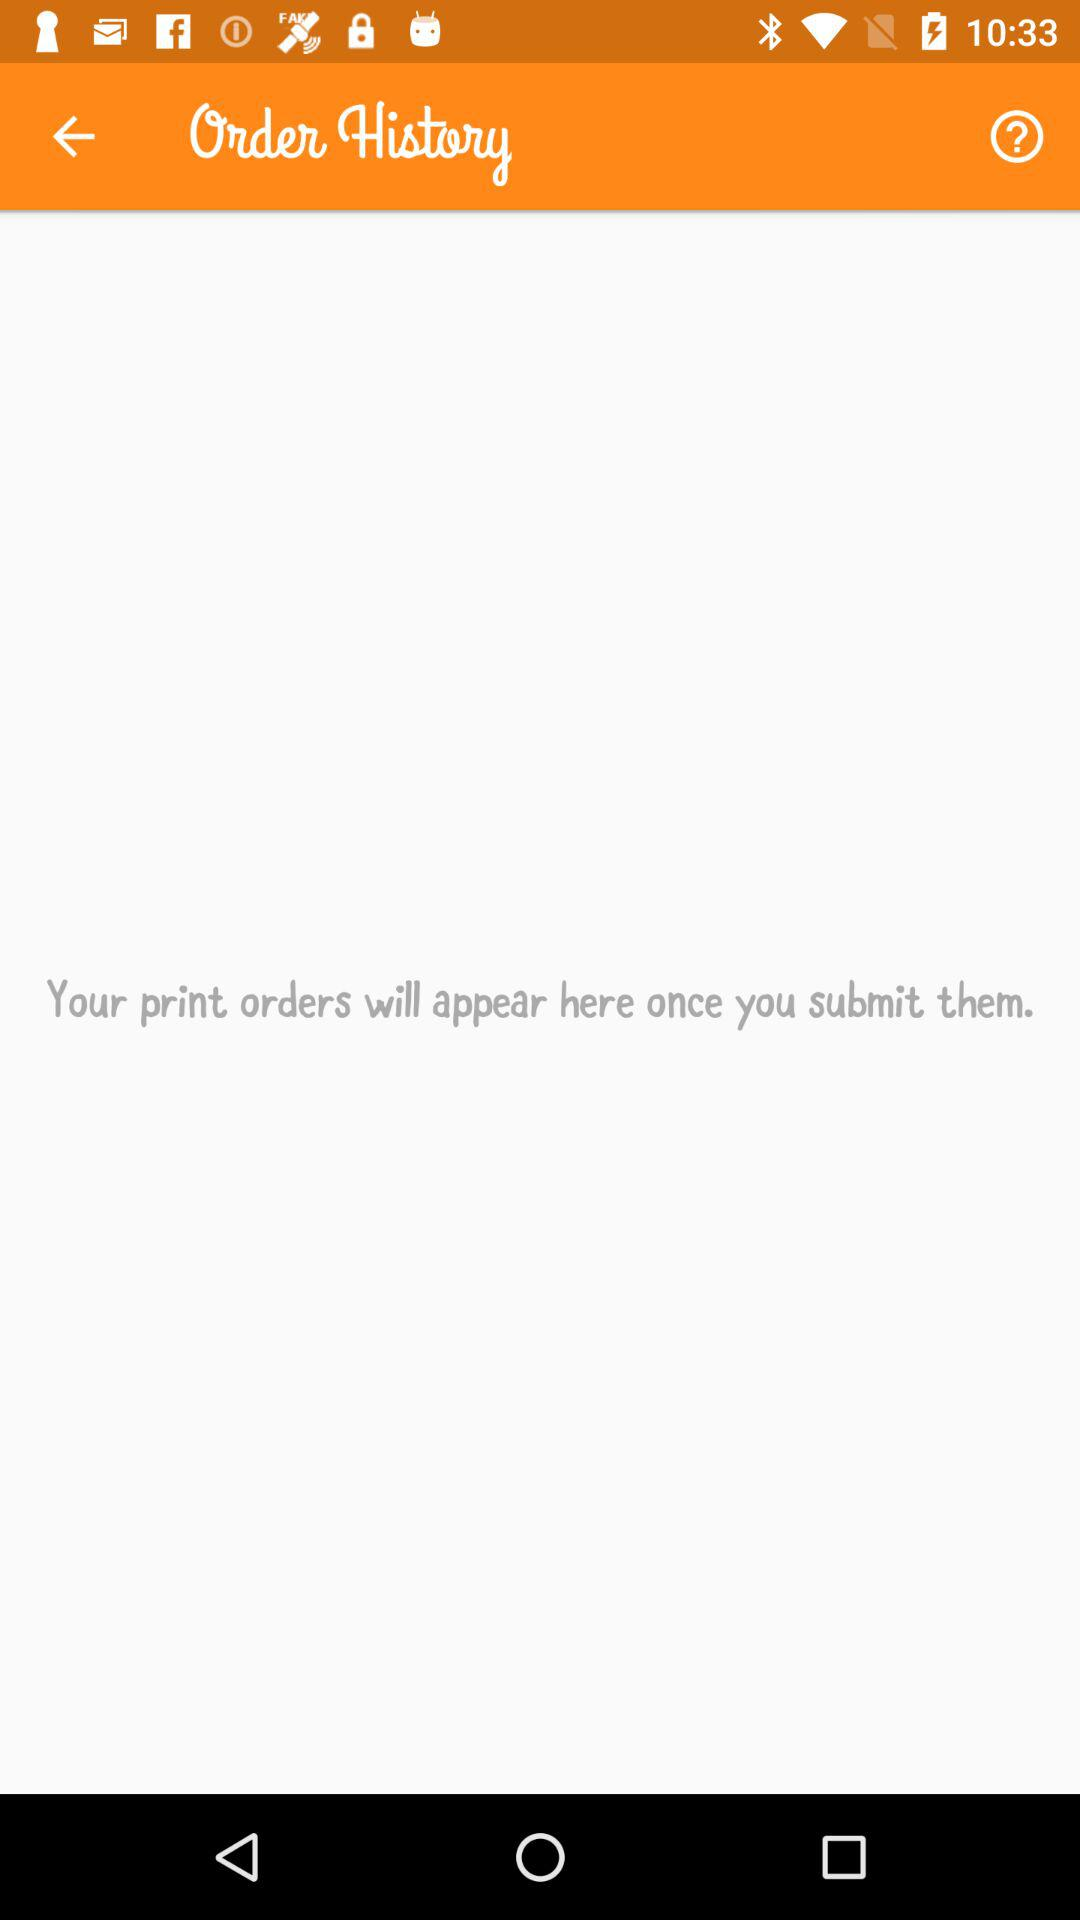When will orders appear in order history? The order will appear in order history "once you submit them". 